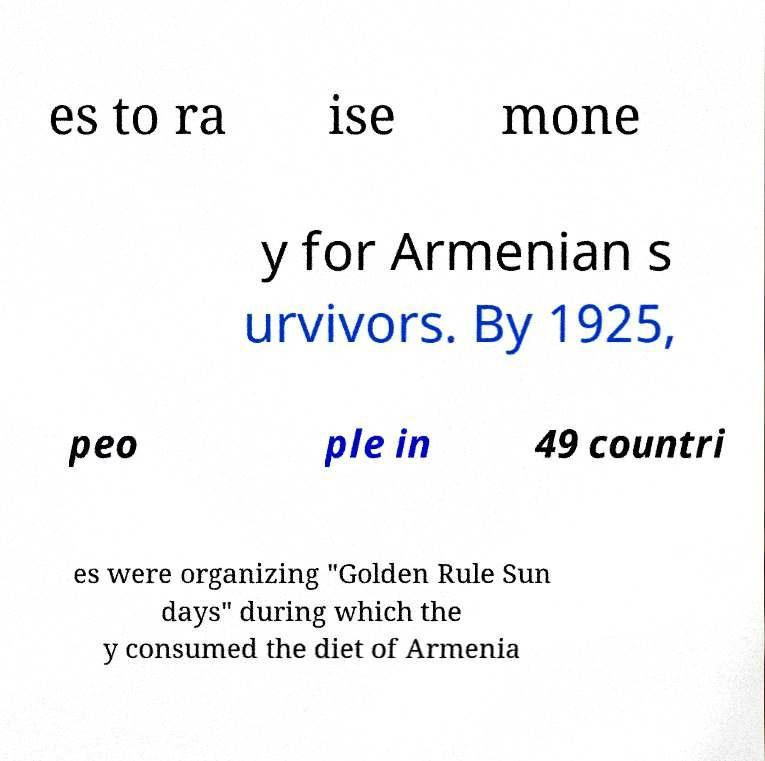There's text embedded in this image that I need extracted. Can you transcribe it verbatim? es to ra ise mone y for Armenian s urvivors. By 1925, peo ple in 49 countri es were organizing "Golden Rule Sun days" during which the y consumed the diet of Armenia 